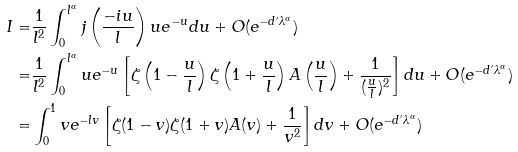<formula> <loc_0><loc_0><loc_500><loc_500>I = & \frac { 1 } { l ^ { 2 } } \int _ { 0 } ^ { l ^ { \alpha } } j \left ( \frac { - i u } { l } \right ) u e ^ { - u } d u + O ( e ^ { - d ^ { \prime } \lambda ^ { \alpha } } ) \\ = & \frac { 1 } { l ^ { 2 } } \int _ { 0 } ^ { l ^ { \alpha } } u e ^ { - u } \left [ \zeta \left ( 1 - \frac { u } { l } \right ) \zeta \left ( 1 + \frac { u } { l } \right ) A \left ( \frac { u } { l } \right ) + \frac { 1 } { ( \frac { u } { l } ) ^ { 2 } } \right ] d u + O ( e ^ { - d ^ { \prime } \lambda ^ { \alpha } } ) \\ = & \int _ { 0 } ^ { 1 } v e ^ { - l v } \left [ \zeta ( 1 - v ) \zeta ( 1 + v ) A ( v ) + \frac { 1 } { v ^ { 2 } } \right ] d v + O ( e ^ { - d ^ { \prime } \lambda ^ { \alpha } } )</formula> 